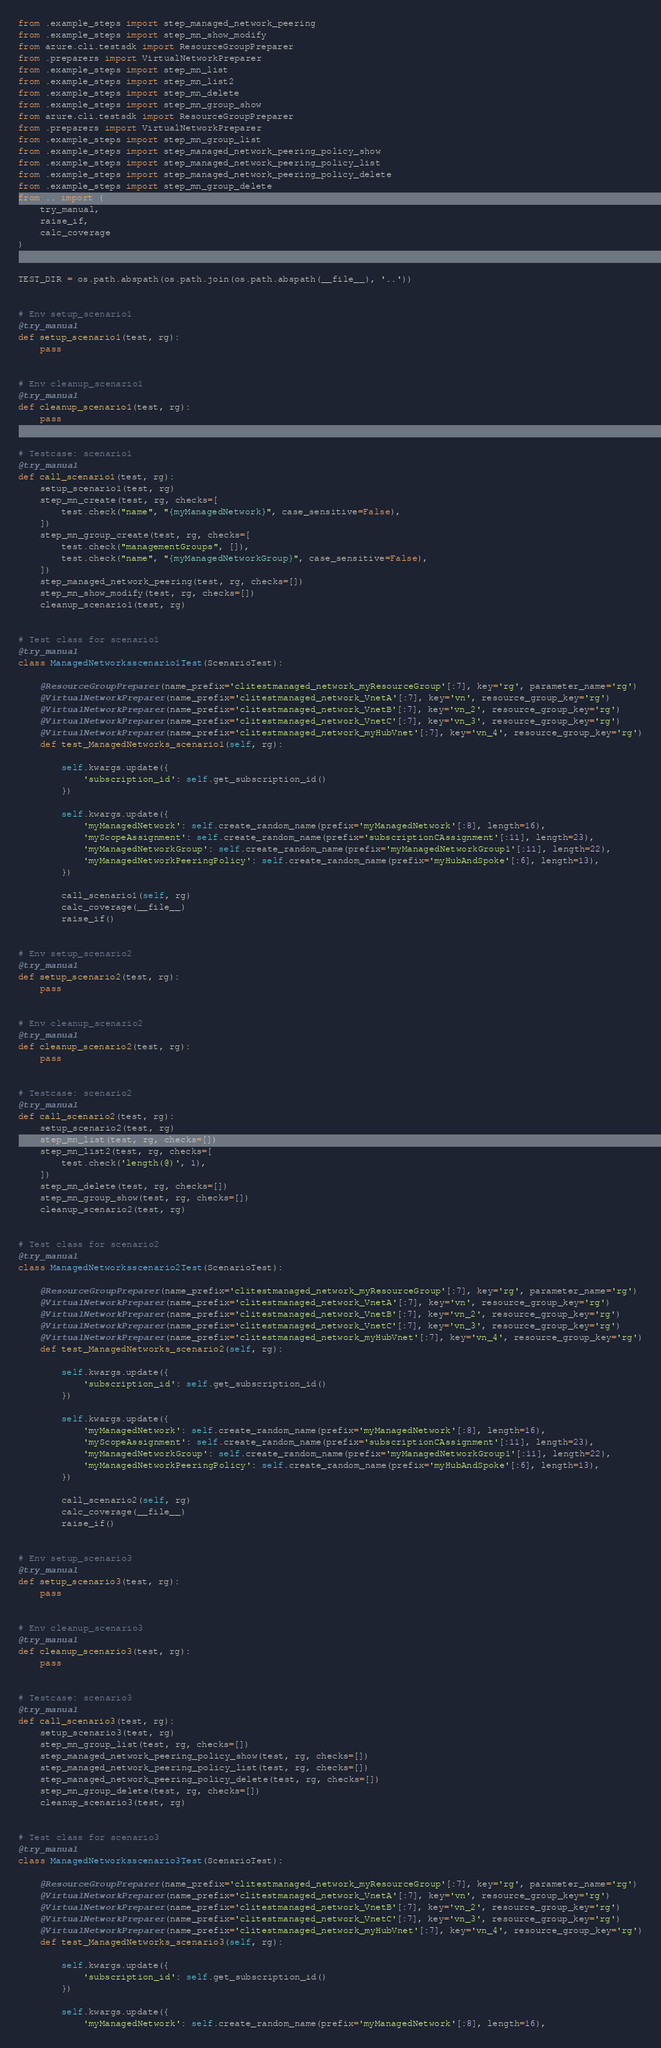Convert code to text. <code><loc_0><loc_0><loc_500><loc_500><_Python_>from .example_steps import step_managed_network_peering
from .example_steps import step_mn_show_modify
from azure.cli.testsdk import ResourceGroupPreparer
from .preparers import VirtualNetworkPreparer
from .example_steps import step_mn_list
from .example_steps import step_mn_list2
from .example_steps import step_mn_delete
from .example_steps import step_mn_group_show
from azure.cli.testsdk import ResourceGroupPreparer
from .preparers import VirtualNetworkPreparer
from .example_steps import step_mn_group_list
from .example_steps import step_managed_network_peering_policy_show
from .example_steps import step_managed_network_peering_policy_list
from .example_steps import step_managed_network_peering_policy_delete
from .example_steps import step_mn_group_delete
from .. import (
    try_manual,
    raise_if,
    calc_coverage
)


TEST_DIR = os.path.abspath(os.path.join(os.path.abspath(__file__), '..'))


# Env setup_scenario1
@try_manual
def setup_scenario1(test, rg):
    pass


# Env cleanup_scenario1
@try_manual
def cleanup_scenario1(test, rg):
    pass


# Testcase: scenario1
@try_manual
def call_scenario1(test, rg):
    setup_scenario1(test, rg)
    step_mn_create(test, rg, checks=[
        test.check("name", "{myManagedNetwork}", case_sensitive=False),
    ])
    step_mn_group_create(test, rg, checks=[
        test.check("managementGroups", []),
        test.check("name", "{myManagedNetworkGroup}", case_sensitive=False),
    ])
    step_managed_network_peering(test, rg, checks=[])
    step_mn_show_modify(test, rg, checks=[])
    cleanup_scenario1(test, rg)


# Test class for scenario1
@try_manual
class ManagedNetworksscenario1Test(ScenarioTest):

    @ResourceGroupPreparer(name_prefix='clitestmanaged_network_myResourceGroup'[:7], key='rg', parameter_name='rg')
    @VirtualNetworkPreparer(name_prefix='clitestmanaged_network_VnetA'[:7], key='vn', resource_group_key='rg')
    @VirtualNetworkPreparer(name_prefix='clitestmanaged_network_VnetB'[:7], key='vn_2', resource_group_key='rg')
    @VirtualNetworkPreparer(name_prefix='clitestmanaged_network_VnetC'[:7], key='vn_3', resource_group_key='rg')
    @VirtualNetworkPreparer(name_prefix='clitestmanaged_network_myHubVnet'[:7], key='vn_4', resource_group_key='rg')
    def test_ManagedNetworks_scenario1(self, rg):

        self.kwargs.update({
            'subscription_id': self.get_subscription_id()
        })

        self.kwargs.update({
            'myManagedNetwork': self.create_random_name(prefix='myManagedNetwork'[:8], length=16),
            'myScopeAssignment': self.create_random_name(prefix='subscriptionCAssignment'[:11], length=23),
            'myManagedNetworkGroup': self.create_random_name(prefix='myManagedNetworkGroup1'[:11], length=22),
            'myManagedNetworkPeeringPolicy': self.create_random_name(prefix='myHubAndSpoke'[:6], length=13),
        })

        call_scenario1(self, rg)
        calc_coverage(__file__)
        raise_if()


# Env setup_scenario2
@try_manual
def setup_scenario2(test, rg):
    pass


# Env cleanup_scenario2
@try_manual
def cleanup_scenario2(test, rg):
    pass


# Testcase: scenario2
@try_manual
def call_scenario2(test, rg):
    setup_scenario2(test, rg)
    step_mn_list(test, rg, checks=[])
    step_mn_list2(test, rg, checks=[
        test.check('length(@)', 1),
    ])
    step_mn_delete(test, rg, checks=[])
    step_mn_group_show(test, rg, checks=[])
    cleanup_scenario2(test, rg)


# Test class for scenario2
@try_manual
class ManagedNetworksscenario2Test(ScenarioTest):

    @ResourceGroupPreparer(name_prefix='clitestmanaged_network_myResourceGroup'[:7], key='rg', parameter_name='rg')
    @VirtualNetworkPreparer(name_prefix='clitestmanaged_network_VnetA'[:7], key='vn', resource_group_key='rg')
    @VirtualNetworkPreparer(name_prefix='clitestmanaged_network_VnetB'[:7], key='vn_2', resource_group_key='rg')
    @VirtualNetworkPreparer(name_prefix='clitestmanaged_network_VnetC'[:7], key='vn_3', resource_group_key='rg')
    @VirtualNetworkPreparer(name_prefix='clitestmanaged_network_myHubVnet'[:7], key='vn_4', resource_group_key='rg')
    def test_ManagedNetworks_scenario2(self, rg):

        self.kwargs.update({
            'subscription_id': self.get_subscription_id()
        })

        self.kwargs.update({
            'myManagedNetwork': self.create_random_name(prefix='myManagedNetwork'[:8], length=16),
            'myScopeAssignment': self.create_random_name(prefix='subscriptionCAssignment'[:11], length=23),
            'myManagedNetworkGroup': self.create_random_name(prefix='myManagedNetworkGroup1'[:11], length=22),
            'myManagedNetworkPeeringPolicy': self.create_random_name(prefix='myHubAndSpoke'[:6], length=13),
        })

        call_scenario2(self, rg)
        calc_coverage(__file__)
        raise_if()


# Env setup_scenario3
@try_manual
def setup_scenario3(test, rg):
    pass


# Env cleanup_scenario3
@try_manual
def cleanup_scenario3(test, rg):
    pass


# Testcase: scenario3
@try_manual
def call_scenario3(test, rg):
    setup_scenario3(test, rg)
    step_mn_group_list(test, rg, checks=[])
    step_managed_network_peering_policy_show(test, rg, checks=[])
    step_managed_network_peering_policy_list(test, rg, checks=[])
    step_managed_network_peering_policy_delete(test, rg, checks=[])
    step_mn_group_delete(test, rg, checks=[])
    cleanup_scenario3(test, rg)


# Test class for scenario3
@try_manual
class ManagedNetworksscenario3Test(ScenarioTest):

    @ResourceGroupPreparer(name_prefix='clitestmanaged_network_myResourceGroup'[:7], key='rg', parameter_name='rg')
    @VirtualNetworkPreparer(name_prefix='clitestmanaged_network_VnetA'[:7], key='vn', resource_group_key='rg')
    @VirtualNetworkPreparer(name_prefix='clitestmanaged_network_VnetB'[:7], key='vn_2', resource_group_key='rg')
    @VirtualNetworkPreparer(name_prefix='clitestmanaged_network_VnetC'[:7], key='vn_3', resource_group_key='rg')
    @VirtualNetworkPreparer(name_prefix='clitestmanaged_network_myHubVnet'[:7], key='vn_4', resource_group_key='rg')
    def test_ManagedNetworks_scenario3(self, rg):

        self.kwargs.update({
            'subscription_id': self.get_subscription_id()
        })

        self.kwargs.update({
            'myManagedNetwork': self.create_random_name(prefix='myManagedNetwork'[:8], length=16),</code> 